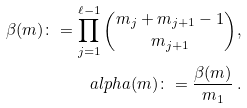Convert formula to latex. <formula><loc_0><loc_0><loc_500><loc_500>\beta ( m ) \colon = \prod _ { j = 1 } ^ { \ell - 1 } \binom { m _ { j } + m _ { j + 1 } - 1 } { m _ { j + 1 } } , \\ a l p h a ( m ) \colon = \frac { \beta ( m ) } { m _ { 1 } } \, .</formula> 